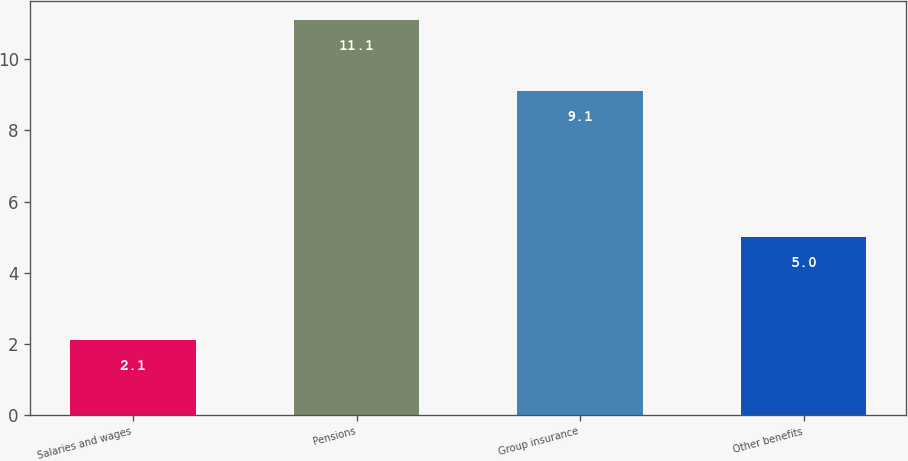Convert chart. <chart><loc_0><loc_0><loc_500><loc_500><bar_chart><fcel>Salaries and wages<fcel>Pensions<fcel>Group insurance<fcel>Other benefits<nl><fcel>2.1<fcel>11.1<fcel>9.1<fcel>5<nl></chart> 